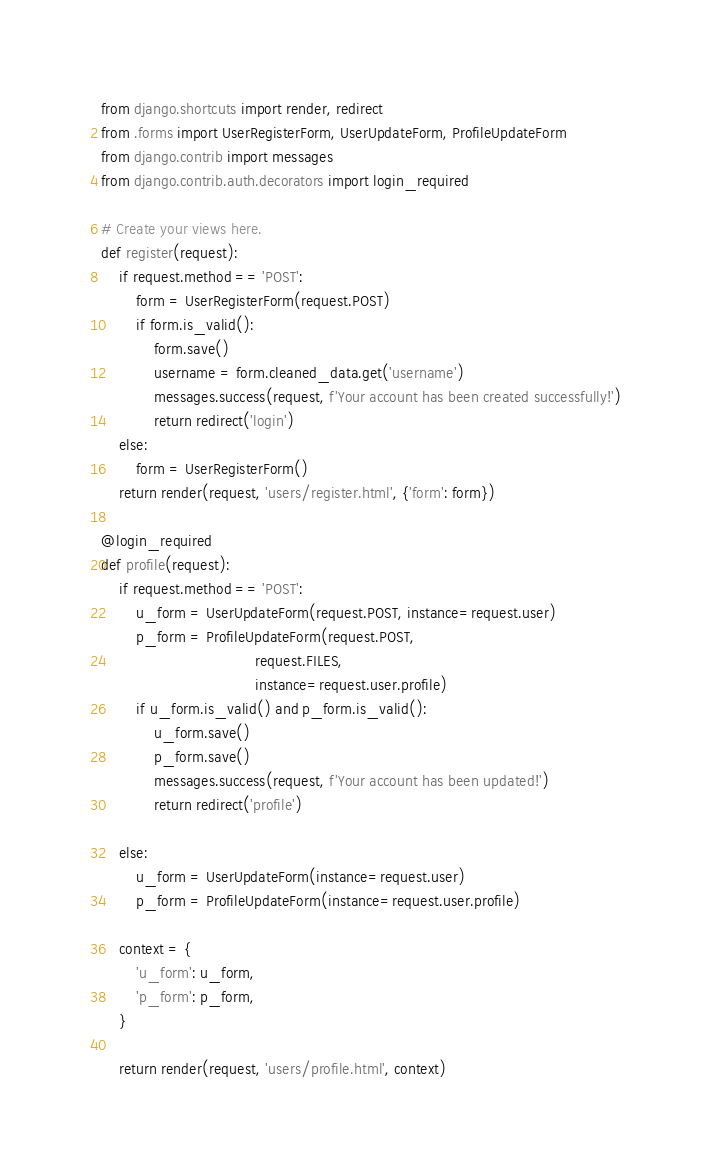<code> <loc_0><loc_0><loc_500><loc_500><_Python_>from django.shortcuts import render, redirect
from .forms import UserRegisterForm, UserUpdateForm, ProfileUpdateForm
from django.contrib import messages
from django.contrib.auth.decorators import login_required

# Create your views here.
def register(request):
    if request.method == 'POST':
        form = UserRegisterForm(request.POST)
        if form.is_valid():
            form.save()
            username = form.cleaned_data.get('username')
            messages.success(request, f'Your account has been created successfully!')
            return redirect('login')
    else:
        form = UserRegisterForm()
    return render(request, 'users/register.html', {'form': form})

@login_required
def profile(request):
    if request.method == 'POST':
        u_form = UserUpdateForm(request.POST, instance=request.user)
        p_form = ProfileUpdateForm(request.POST,
                                   request.FILES,
                                   instance=request.user.profile)
        if u_form.is_valid() and p_form.is_valid():
            u_form.save()
            p_form.save()
            messages.success(request, f'Your account has been updated!')
            return redirect('profile')

    else:
        u_form = UserUpdateForm(instance=request.user)
        p_form = ProfileUpdateForm(instance=request.user.profile)

    context = {
        'u_form': u_form,
        'p_form': p_form,
    }

    return render(request, 'users/profile.html', context)</code> 